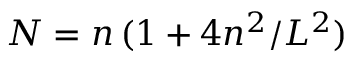Convert formula to latex. <formula><loc_0><loc_0><loc_500><loc_500>N = n \, ( 1 + 4 n ^ { 2 } / L ^ { 2 } )</formula> 